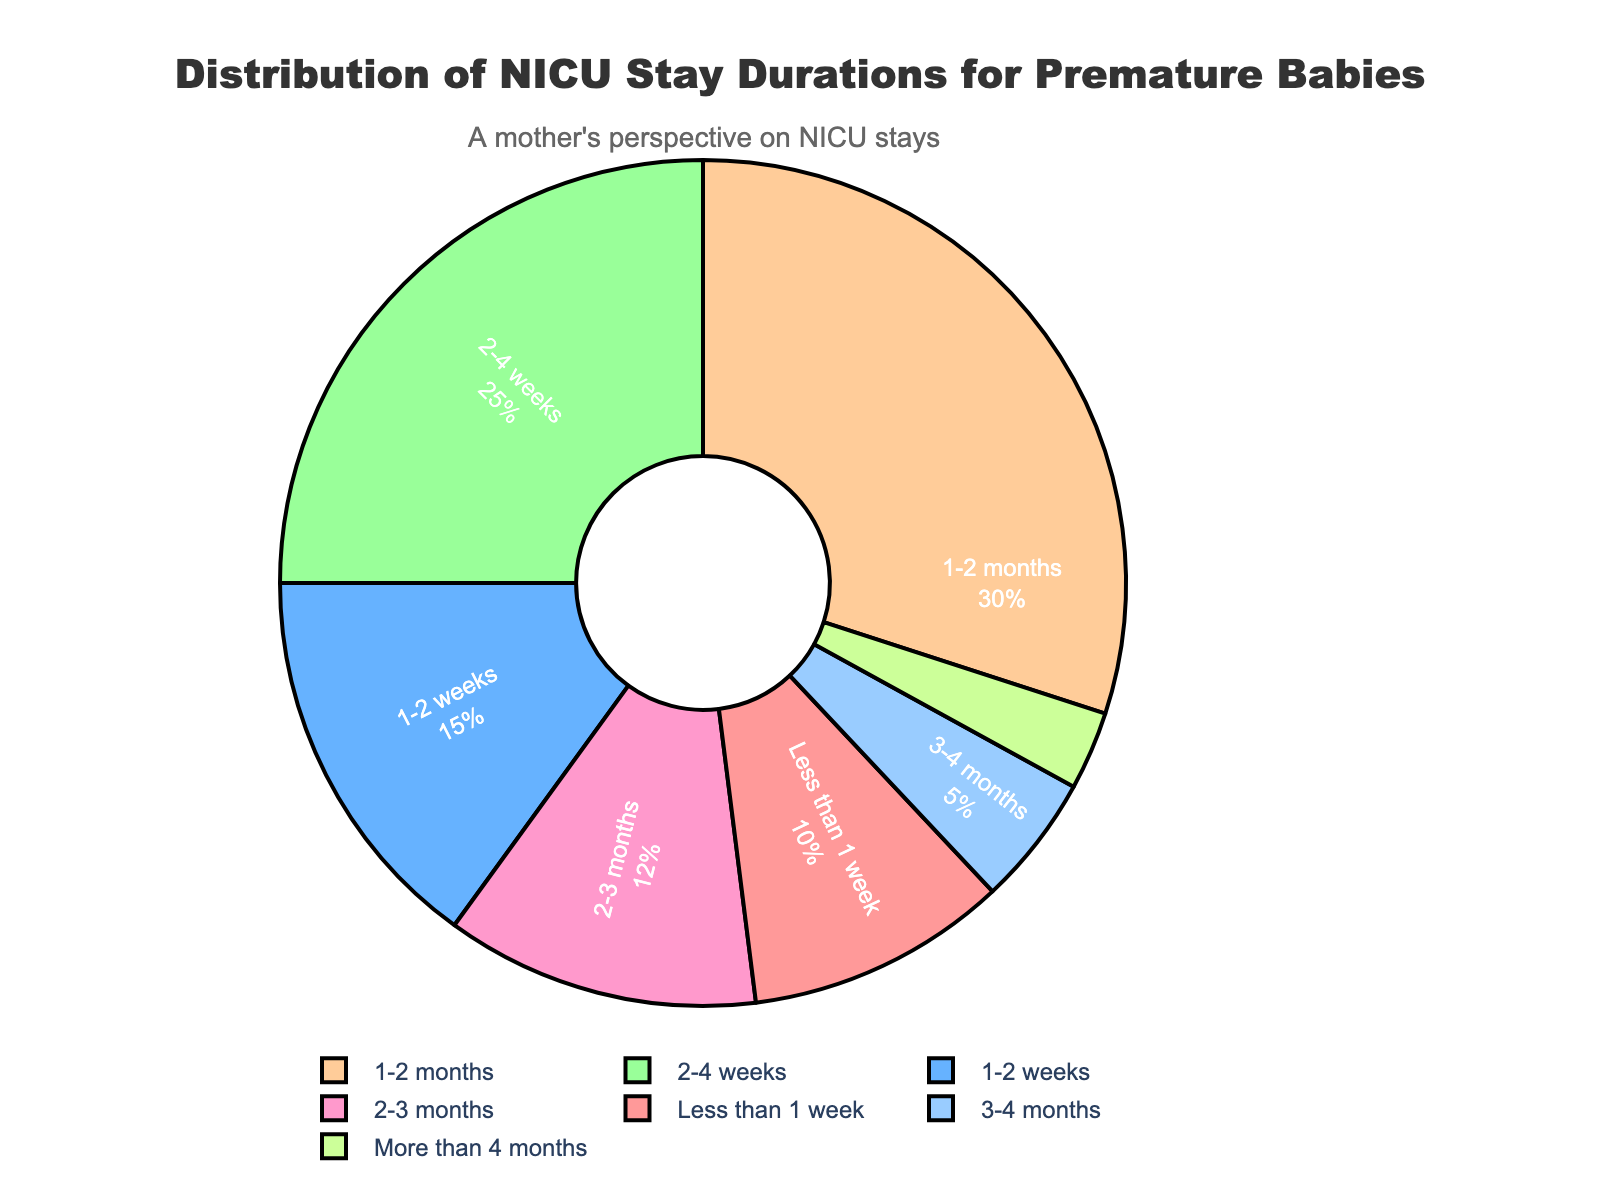What percentage of premature babies stayed in the NICU for "More than 4 months"? The segment labeled "More than 4 months" directly indicates the percentage.
Answer: 3 How much greater is the percentage of babies staying "1-2 months" compared to those staying "3-4 months"? Subtract the percentage of "3-4 months" from the percentage of "1-2 months". "1-2 months" is 30% and "3-4 months" is 5%, so 30% - 5% = 25%.
Answer: 25 Which stay duration category has the largest proportion of NICU stays? Look for the segment with the largest size. The "1-2 months" category has the largest portion at 30%.
Answer: 1-2 months What is the total percentage of babies who stayed in the NICU for less than a month? Add the percentages of the categories "Less than 1 week", "1-2 weeks", and "2-4 weeks". That's 10% + 15% + 25% = 50%.
Answer: 50 Which two categories have the smallest percentages, and what is their combined percentage? Identify the smallest segments, which are "3-4 months" and "More than 4 months" at 5% and 3% respectively. Add them: 5% + 3% = 8%.
Answer: 3-4 months and More than 4 months, 8 What is the difference in percentages between babies staying "2-4 weeks" and those staying "2-3 months"? Subtract the percentage of "2-3 months" from the percentage of "2-4 weeks". "2-4 weeks" is 25% and "2-3 months" is 12%, so 25% - 12% = 13%.
Answer: 13 What percentage of babies stayed in the NICU between 1 week and 1 month? Add the percentages of the categories "1-2 weeks" and "2-4 weeks". That's 15% + 25% = 40%.
Answer: 40 By how much does the combined percentage of "1-2 months" and "2-4 weeks" exceed half of the total percentage? Calculate the sum of "1-2 months" and "2-4 weeks", which is 30% + 25% = 55%. Half of the total percentage (100%) is 50%. The excess is 55% - 50% = 5%.
Answer: 5 What is the percentage difference between the category with the highest percentage and the category with the lowest percentage? Subtract the percentage of the "More than 4 months" category (3%) from the "1-2 months" category (30%). 30% - 3% = 27%.
Answer: 27 